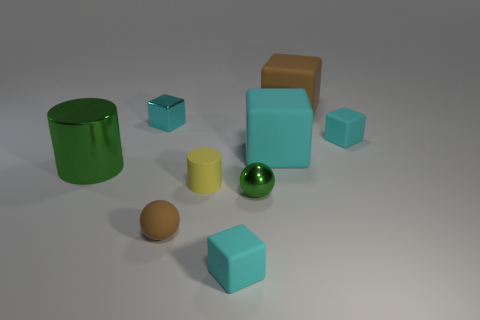There is a brown thing that is the same shape as the big cyan rubber object; what is its size?
Make the answer very short. Large. There is a cyan block that is in front of the tiny metal cube and on the left side of the large cyan matte object; how big is it?
Keep it short and to the point. Small. How many shiny objects are either cylinders or small balls?
Ensure brevity in your answer.  2. What is the material of the large cylinder?
Provide a short and direct response. Metal. There is a tiny thing that is right of the brown matte thing that is to the right of the cyan matte thing that is in front of the green cylinder; what is it made of?
Make the answer very short. Rubber. The brown thing that is the same size as the cyan shiny object is what shape?
Offer a very short reply. Sphere. How many things are small gray shiny cylinders or tiny cyan blocks behind the tiny cylinder?
Keep it short and to the point. 2. Does the tiny cube that is in front of the big cyan block have the same material as the brown thing right of the green metal ball?
Keep it short and to the point. Yes. The small thing that is the same color as the big metal object is what shape?
Offer a very short reply. Sphere. How many brown things are either big cubes or small matte blocks?
Provide a short and direct response. 1. 